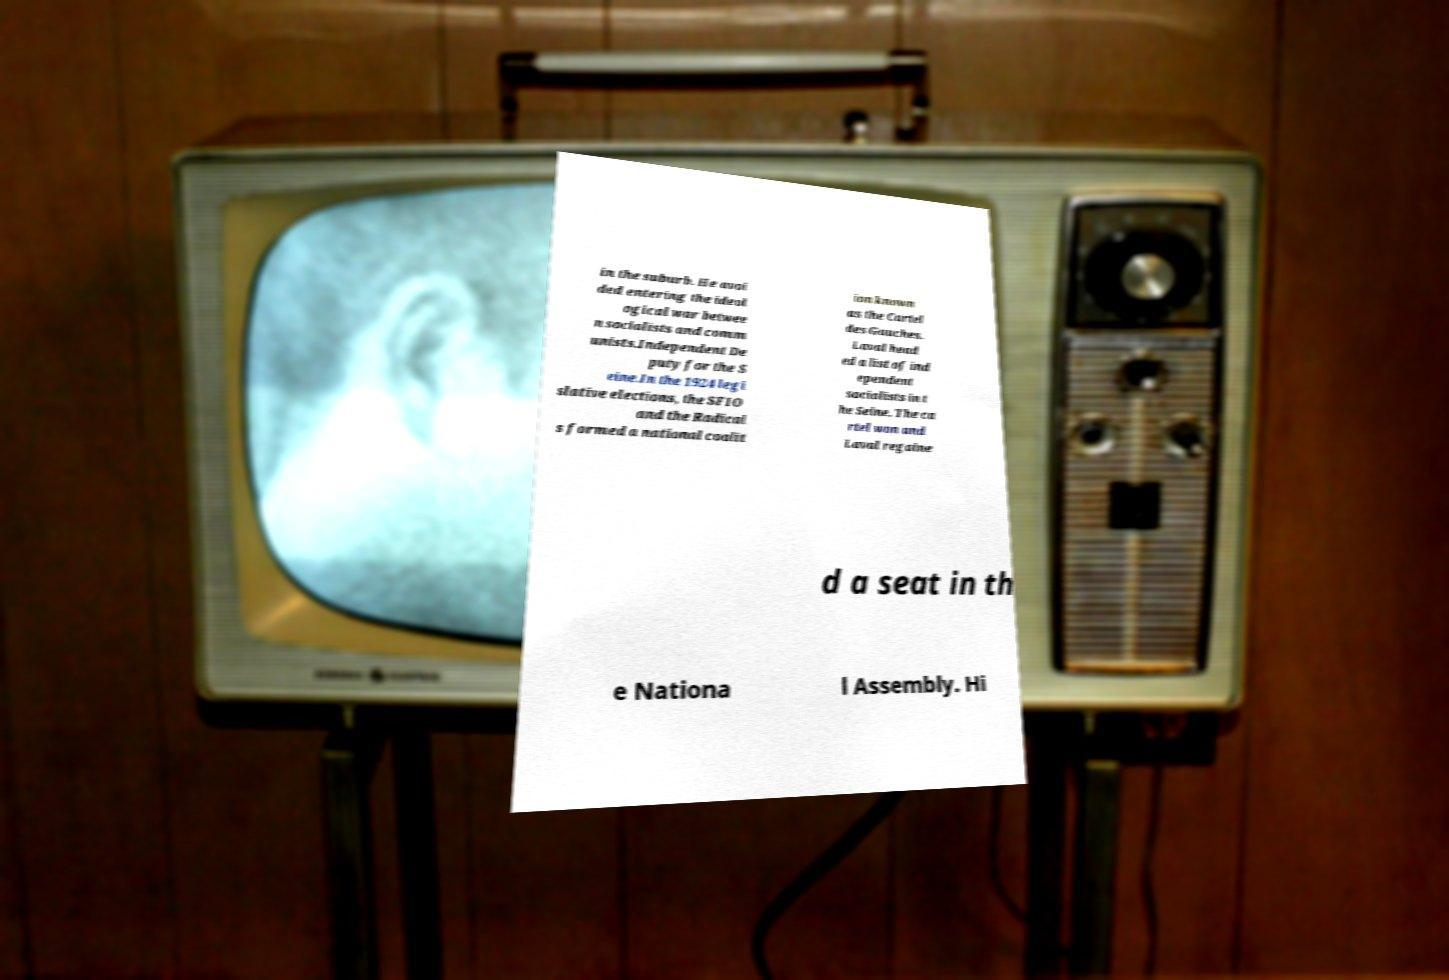For documentation purposes, I need the text within this image transcribed. Could you provide that? in the suburb. He avoi ded entering the ideol ogical war betwee n socialists and comm unists.Independent De puty for the S eine.In the 1924 legi slative elections, the SFIO and the Radical s formed a national coalit ion known as the Cartel des Gauches. Laval head ed a list of ind ependent socialists in t he Seine. The ca rtel won and Laval regaine d a seat in th e Nationa l Assembly. Hi 